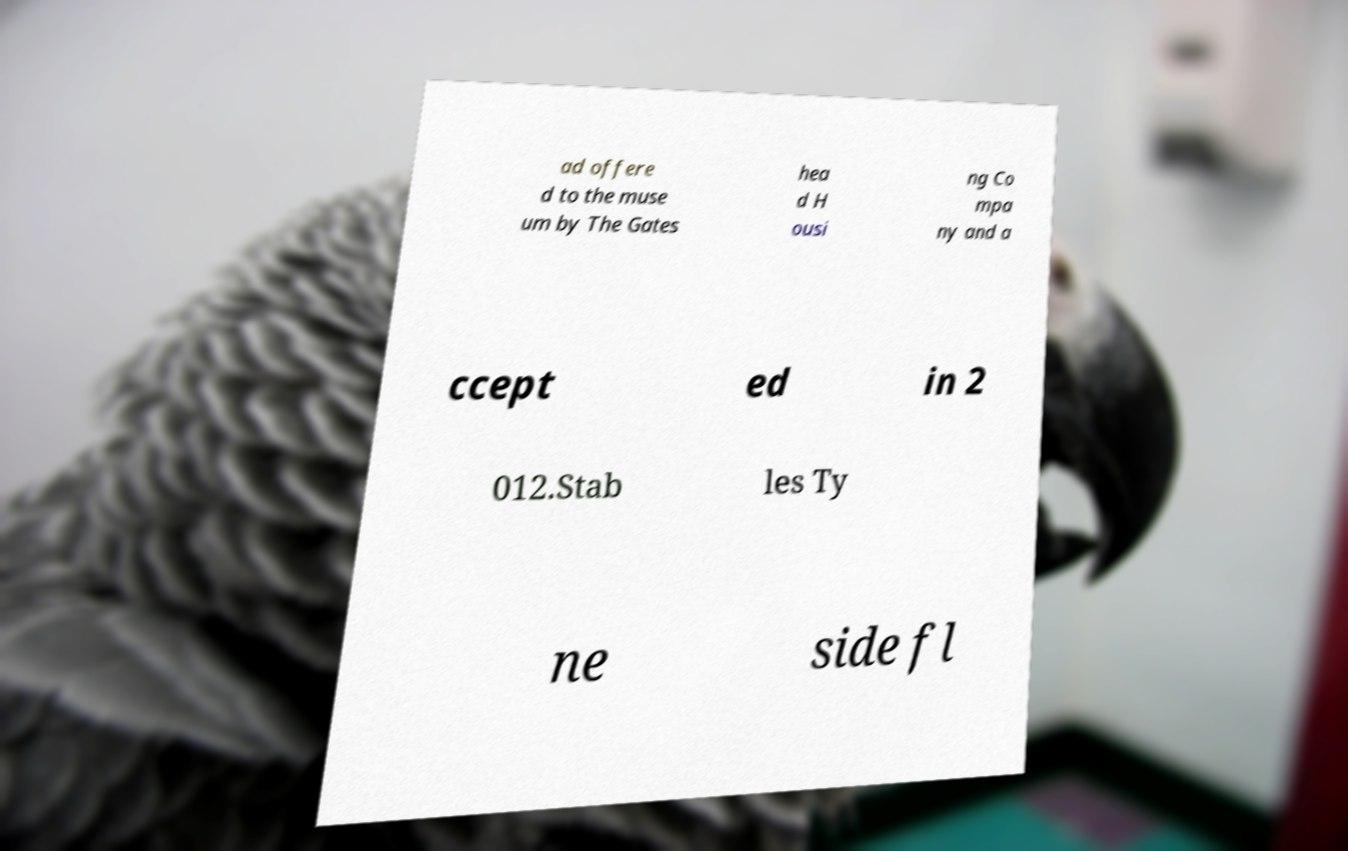Please identify and transcribe the text found in this image. ad offere d to the muse um by The Gates hea d H ousi ng Co mpa ny and a ccept ed in 2 012.Stab les Ty ne side fl 